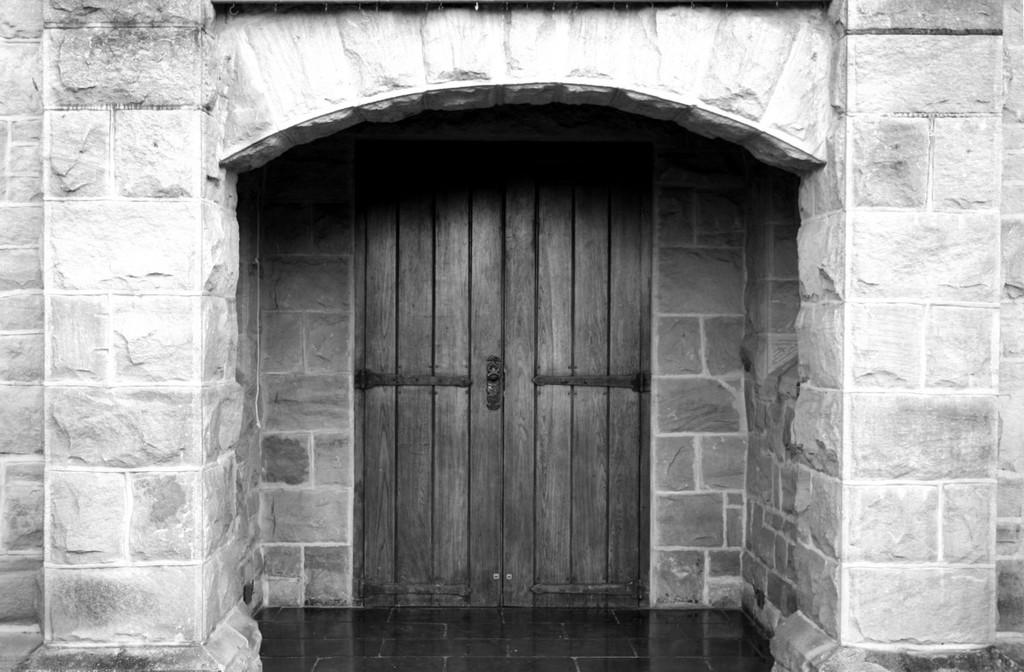What is the main structure visible in the foreground of the image? There is an arch in the foreground of the image. Is the arch part of a larger structure? Yes, the arch is connected to a wall. What can be seen in the background of the image? There is a wooden door in the background of the image. What date is marked on the calendar in the image? There is no calendar present in the image. How long does it take for the vest to dry in the image? There is no vest present in the image. 